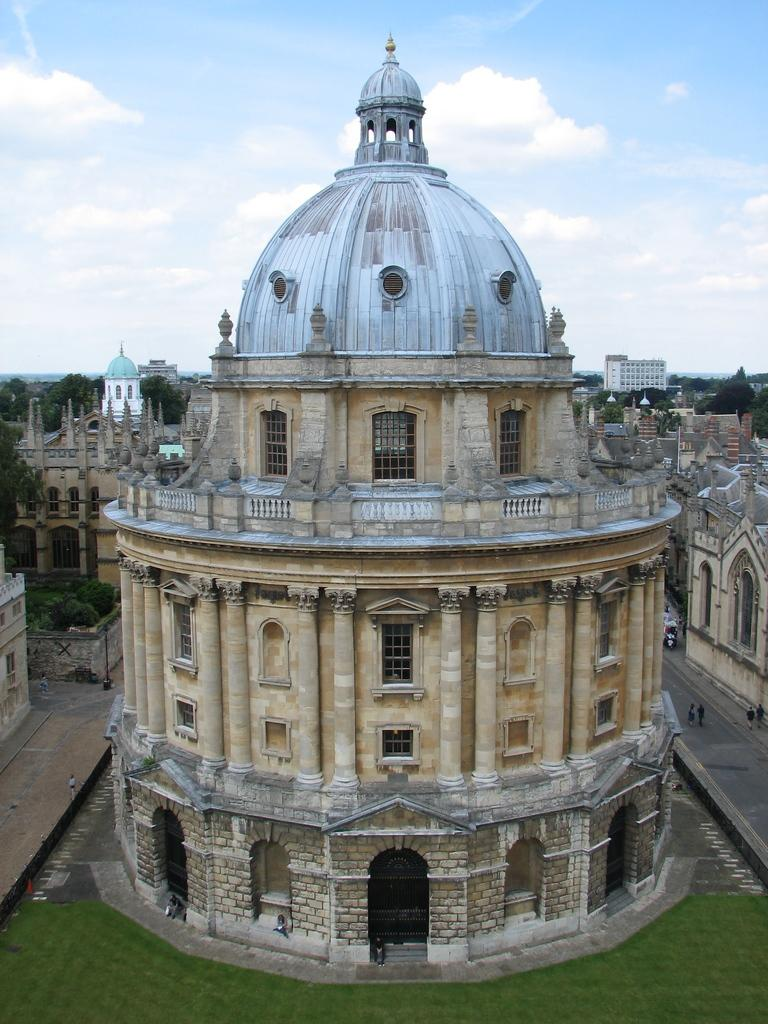What type of structures can be seen in the image? There are buildings in the image. What type of vegetation is present in the image? There are trees with green color in the image. What colors can be seen in the sky in the image? The sky is blue and white in color. What verse is being recited by the trees in the image? There is no verse being recited by the trees in the image, as trees do not have the ability to recite verses. 